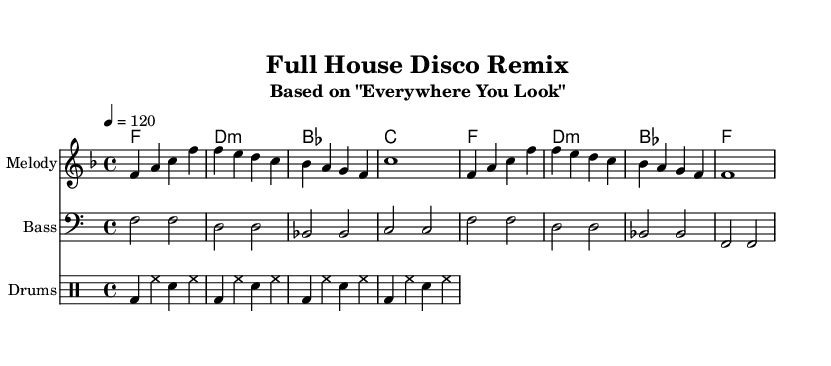What is the key signature of this music? The music is in F major, which has one flat (B flat) in its key signature. You can determine the key signature by looking at the beginning of the staff where the key signature is shown.
Answer: F major What is the time signature of this music? The time signature is 4/4, which means there are four beats in each measure and the quarter note gets one beat. You can find the time signature indicated at the beginning of the piece, typically right after the key signature.
Answer: 4/4 What is the tempo marking for this music? The tempo marking is quarter note equals 120 beats per minute, indicating the speed of the music. This is stated right after the time signature.
Answer: 120 How many measures are in the melody? The melody consists of four measures, which can be counted by looking at the vertical lines separating the sections on the staff. Each of these lines represents a measure.
Answer: Four What instrument is indicated for the melody? The melody is indicated for the instrument named "Melody" in the score. This is specified at the beginning of the staff on which the melody is written.
Answer: Melody What type of chord is shown in the second measure of harmony? The second measure of harmony shows a D minor chord, which can be determined by identifying the notes that make up the chord and recognizing the minor quality based on the interval structure.
Answer: D minor What is the primary genre represented in this remix? The primary genre represented in this remix is Disco, which is typically characterized by its upbeat rhythm and danceable style. This connection can be made from the distinct drum and bass patterns used throughout the piece.
Answer: Disco 